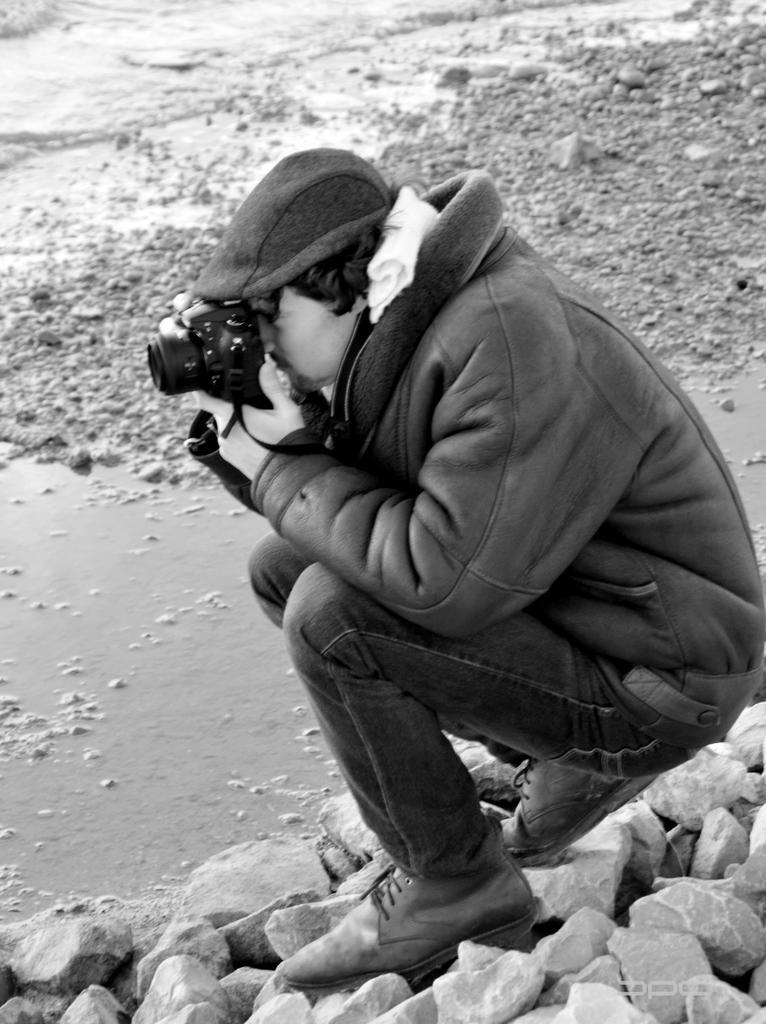How would you summarize this image in a sentence or two? a person is holding a camera in his hand , sitting on the stones. in front of him there is little water. 